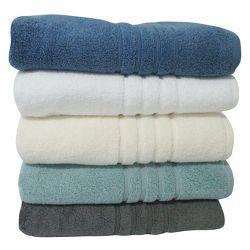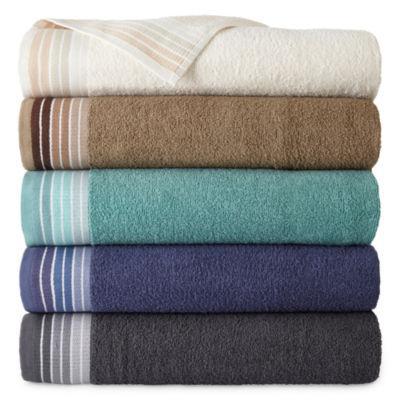The first image is the image on the left, the second image is the image on the right. Analyze the images presented: Is the assertion "There are more towels in the right image than in the left image." valid? Answer yes or no. No. The first image is the image on the left, the second image is the image on the right. Considering the images on both sides, is "There are ten towels." valid? Answer yes or no. Yes. 